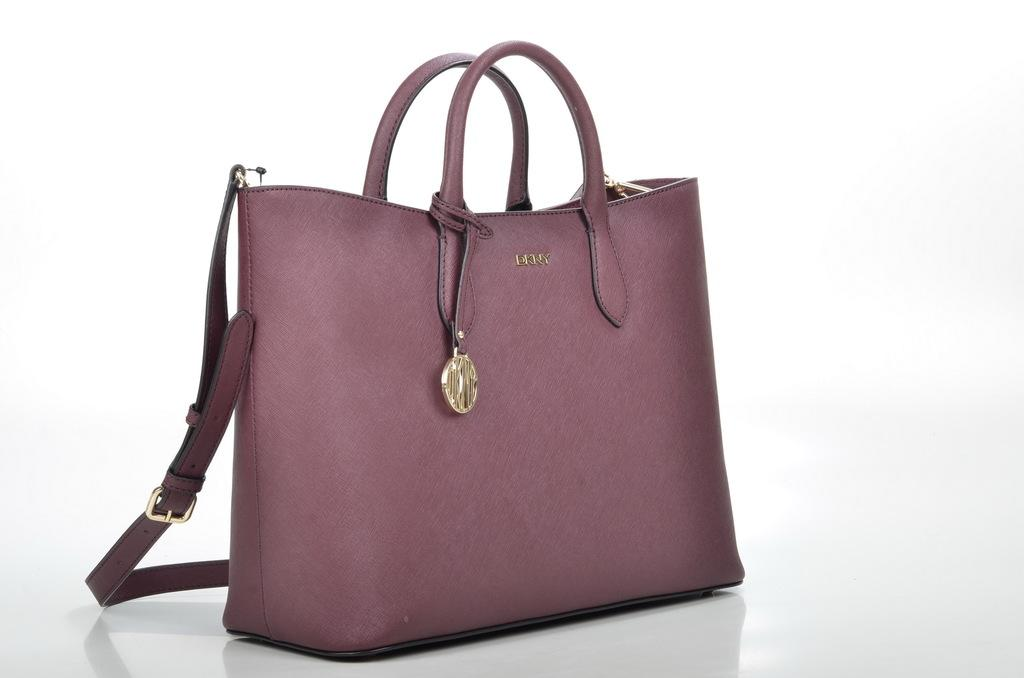What object can be seen in the image? There is a bag in the image. What is the color of the bag? The bag is maroon in color. Can you see the fingerprints on the bag in the image? There is no mention of fingerprints or any indication that they are visible on the bag in the image. 